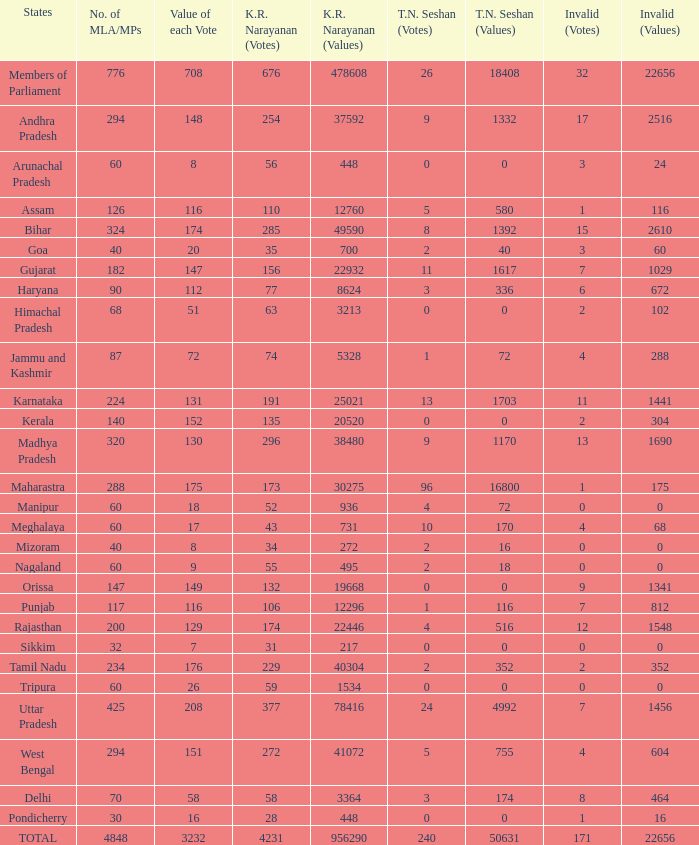Name the most kr votes for value of each vote for 208 377.0. 